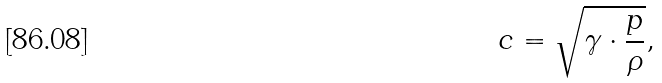Convert formula to latex. <formula><loc_0><loc_0><loc_500><loc_500>c = { \sqrt { \gamma \cdot { \frac { p } { \rho } } } } ,</formula> 